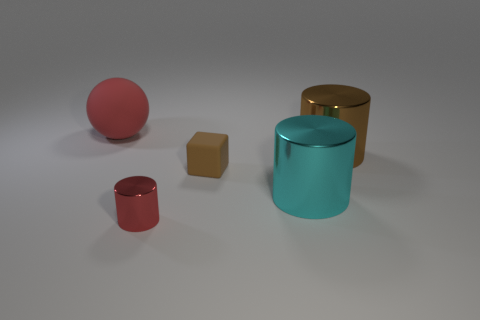How many large cyan things are there?
Ensure brevity in your answer.  1. There is a metallic thing that is the same size as the brown cube; what is its color?
Keep it short and to the point. Red. Does the thing left of the red cylinder have the same material as the red object right of the big red sphere?
Give a very brief answer. No. There is a metallic cylinder that is on the left side of the brown cube behind the red cylinder; what size is it?
Your answer should be compact. Small. There is a small thing in front of the small matte thing; what material is it?
Your answer should be very brief. Metal. How many things are large shiny objects that are behind the small red thing or small things that are on the left side of the tiny matte thing?
Give a very brief answer. 3. What is the material of the big cyan thing that is the same shape as the tiny shiny thing?
Your answer should be very brief. Metal. Is the color of the shiny thing that is behind the tiny matte thing the same as the small thing in front of the large cyan metal cylinder?
Make the answer very short. No. Is there a red shiny cylinder of the same size as the brown metal cylinder?
Provide a short and direct response. No. What is the material of the thing that is behind the cyan shiny cylinder and in front of the large brown shiny cylinder?
Your response must be concise. Rubber. 